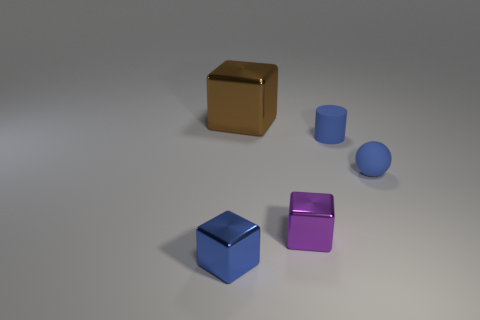Add 2 large cyan metal objects. How many objects exist? 7 Subtract all cubes. How many objects are left? 2 Subtract all tiny cyan objects. Subtract all small purple metal blocks. How many objects are left? 4 Add 2 brown metal cubes. How many brown metal cubes are left? 3 Add 3 cyan balls. How many cyan balls exist? 3 Subtract 0 yellow cylinders. How many objects are left? 5 